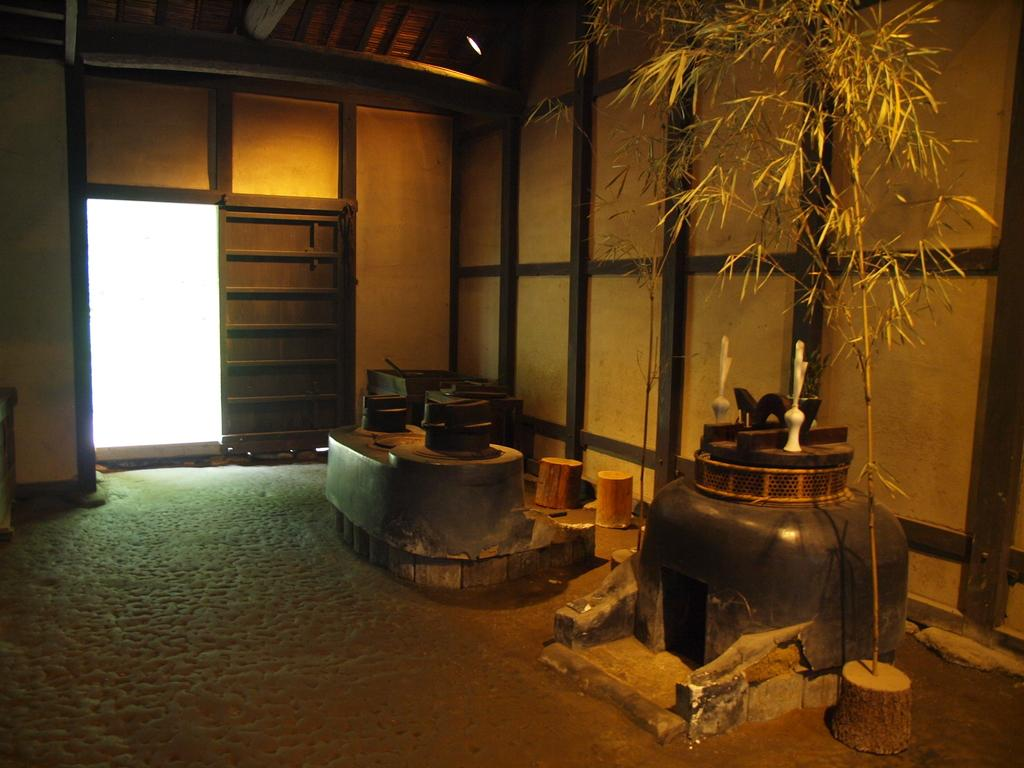What type of feature can be seen in the image? There is a fireplace in the image. What other objects are present in the image? There are houseplants in the image. Is there any entrance or exit visible in the image? Yes, there is a door in the image. Where is the image taken? The image is set inside a building. What part of the building is bursting in the image? There is no part of the building bursting in the image; it is set inside a building without any signs of destruction. 